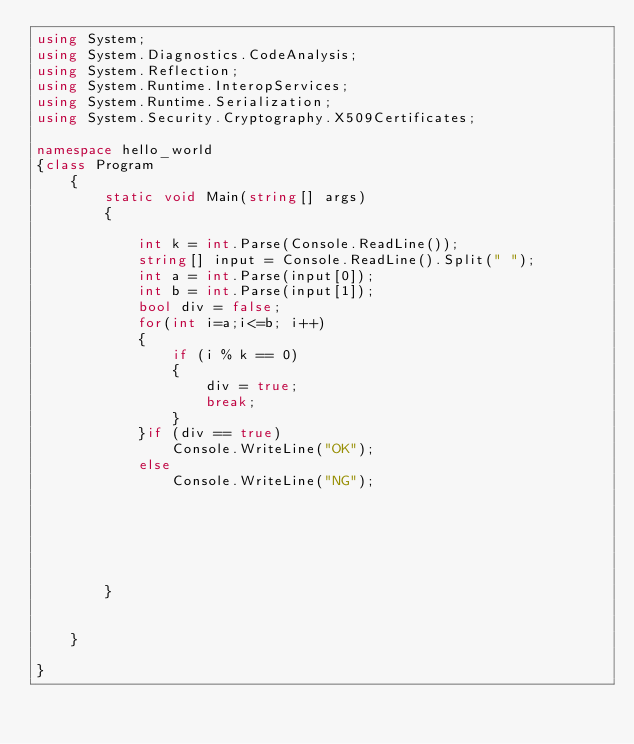Convert code to text. <code><loc_0><loc_0><loc_500><loc_500><_C#_>using System;
using System.Diagnostics.CodeAnalysis;
using System.Reflection;
using System.Runtime.InteropServices;
using System.Runtime.Serialization;
using System.Security.Cryptography.X509Certificates;

namespace hello_world
{class Program
	{
		static void Main(string[] args)
		{

			int k = int.Parse(Console.ReadLine());
			string[] input = Console.ReadLine().Split(" ");
			int a = int.Parse(input[0]);
			int b = int.Parse(input[1]);
			bool div = false;
			for(int i=a;i<=b; i++)
			{
				if (i % k == 0)
				{
					div = true;
					break;
				}
			}if (div == true)
				Console.WriteLine("OK");
			else
				Console.WriteLine("NG");

		
				
	
			
			
		}

		
	}

}
</code> 